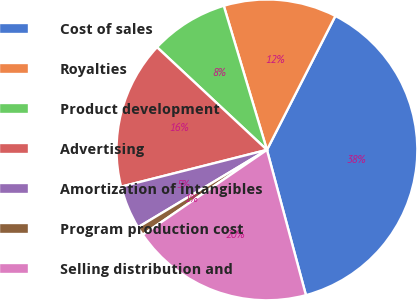<chart> <loc_0><loc_0><loc_500><loc_500><pie_chart><fcel>Cost of sales<fcel>Royalties<fcel>Product development<fcel>Advertising<fcel>Amortization of intangibles<fcel>Program production cost<fcel>Selling distribution and<nl><fcel>38.31%<fcel>12.15%<fcel>8.41%<fcel>15.89%<fcel>4.67%<fcel>0.94%<fcel>19.63%<nl></chart> 